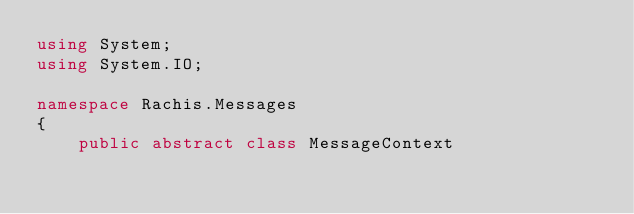Convert code to text. <code><loc_0><loc_0><loc_500><loc_500><_C#_>using System;
using System.IO;

namespace Rachis.Messages
{
    public abstract class MessageContext</code> 